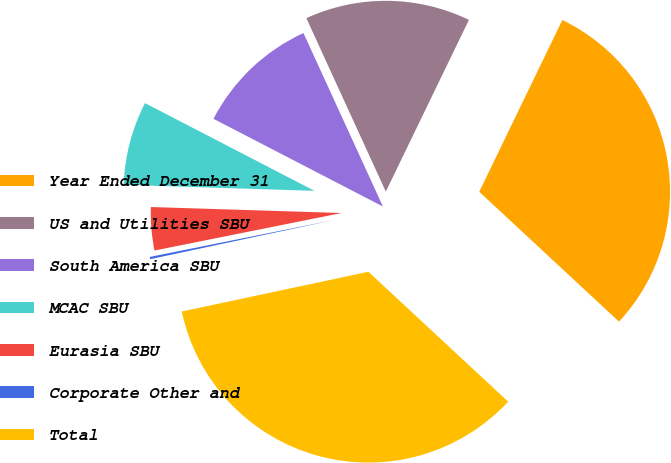<chart> <loc_0><loc_0><loc_500><loc_500><pie_chart><fcel>Year Ended December 31<fcel>US and Utilities SBU<fcel>South America SBU<fcel>MCAC SBU<fcel>Eurasia SBU<fcel>Corporate Other and<fcel>Total<nl><fcel>29.74%<fcel>14.01%<fcel>10.56%<fcel>7.1%<fcel>3.65%<fcel>0.19%<fcel>34.74%<nl></chart> 